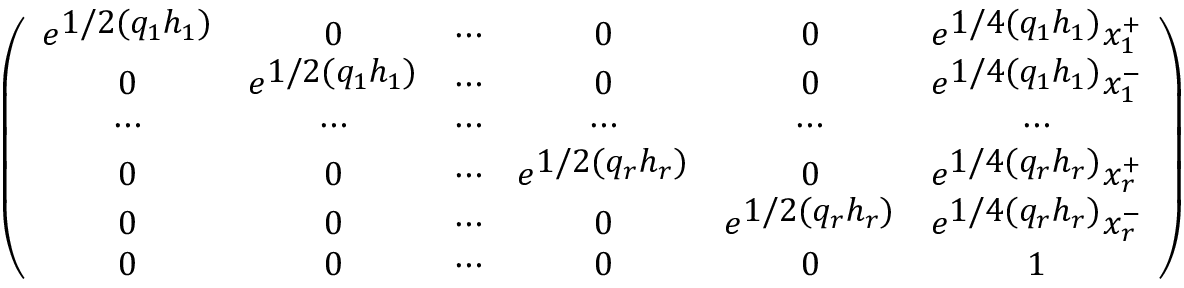<formula> <loc_0><loc_0><loc_500><loc_500>\left ( \begin{array} { c c c c c c } { { e ^ { 1 / 2 ( q _ { 1 } h _ { 1 } ) } } } & { 0 } & { \cdots } & { 0 } & { 0 } & { { e ^ { 1 / 4 ( q _ { 1 } h _ { 1 } ) } x _ { 1 } ^ { + } } } \\ { 0 } & { { e ^ { 1 / 2 ( q _ { 1 } h _ { 1 } ) } } } & { \cdots } & { 0 } & { 0 } & { { e ^ { 1 / 4 ( q _ { 1 } h _ { 1 } ) } x _ { 1 } ^ { - } } } \\ { \cdots } & { \cdots } & { \cdots } & { \cdots } & { \cdots } & { \cdots } \\ { 0 } & { 0 } & { \cdots } & { { e ^ { 1 / 2 ( q _ { r } h _ { r } ) } } } & { 0 } & { { e ^ { 1 / 4 ( q _ { r } h _ { r } ) } x _ { r } ^ { + } } } \\ { 0 } & { 0 } & { \cdots } & { 0 } & { { e ^ { 1 / 2 ( q _ { r } h _ { r } ) } } } & { { e ^ { 1 / 4 ( q _ { r } h _ { r } ) } x _ { r } ^ { - } } } \\ { 0 } & { 0 } & { \cdots } & { 0 } & { 0 } & { 1 } \end{array} \right )</formula> 